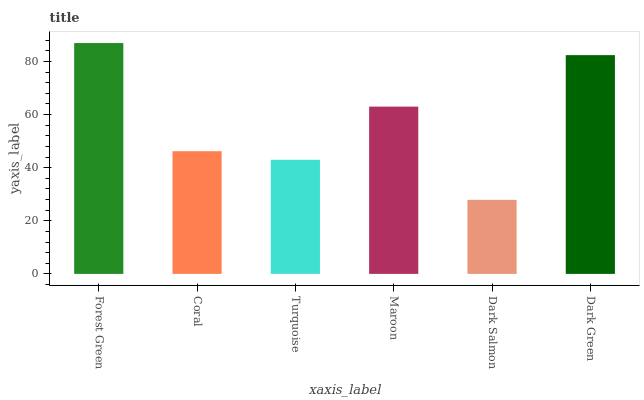Is Dark Salmon the minimum?
Answer yes or no. Yes. Is Forest Green the maximum?
Answer yes or no. Yes. Is Coral the minimum?
Answer yes or no. No. Is Coral the maximum?
Answer yes or no. No. Is Forest Green greater than Coral?
Answer yes or no. Yes. Is Coral less than Forest Green?
Answer yes or no. Yes. Is Coral greater than Forest Green?
Answer yes or no. No. Is Forest Green less than Coral?
Answer yes or no. No. Is Maroon the high median?
Answer yes or no. Yes. Is Coral the low median?
Answer yes or no. Yes. Is Dark Green the high median?
Answer yes or no. No. Is Dark Salmon the low median?
Answer yes or no. No. 